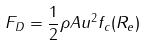Convert formula to latex. <formula><loc_0><loc_0><loc_500><loc_500>F _ { D } = \frac { 1 } { 2 } \rho A u ^ { 2 } f _ { c } ( R _ { e } )</formula> 